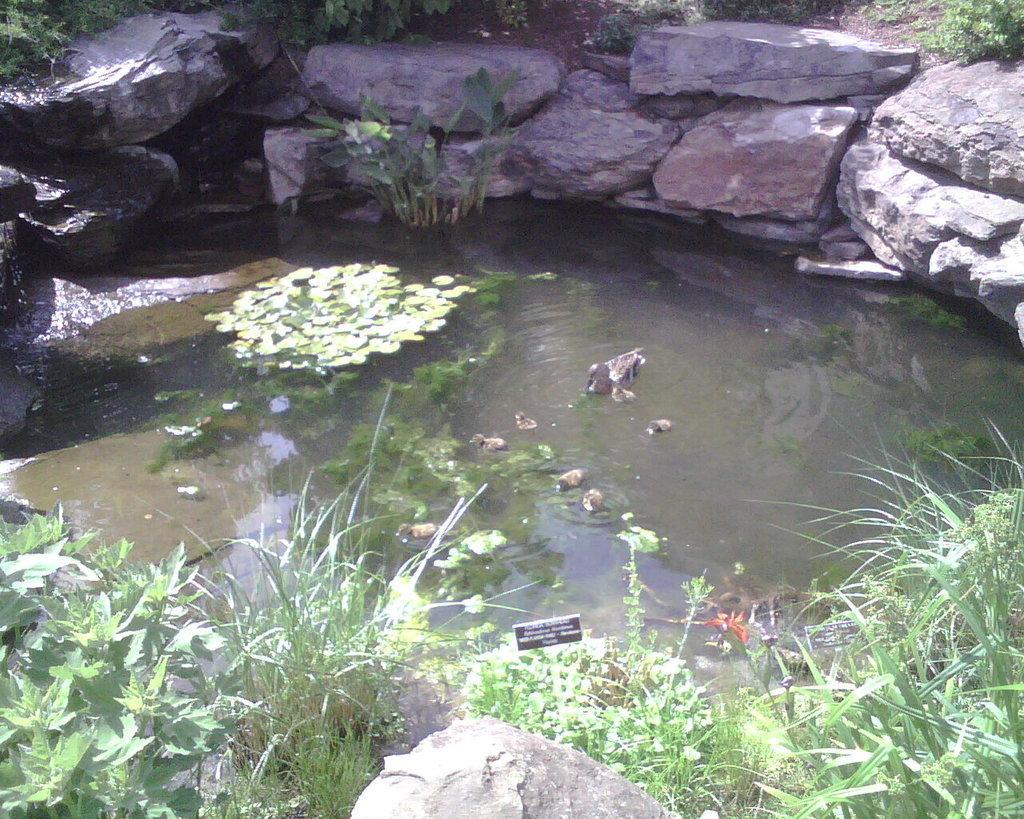How would you summarize this image in a sentence or two? In this picture there is water in the center of the image, which contains algae and there are rocks around the water and there is greenery in the image. 